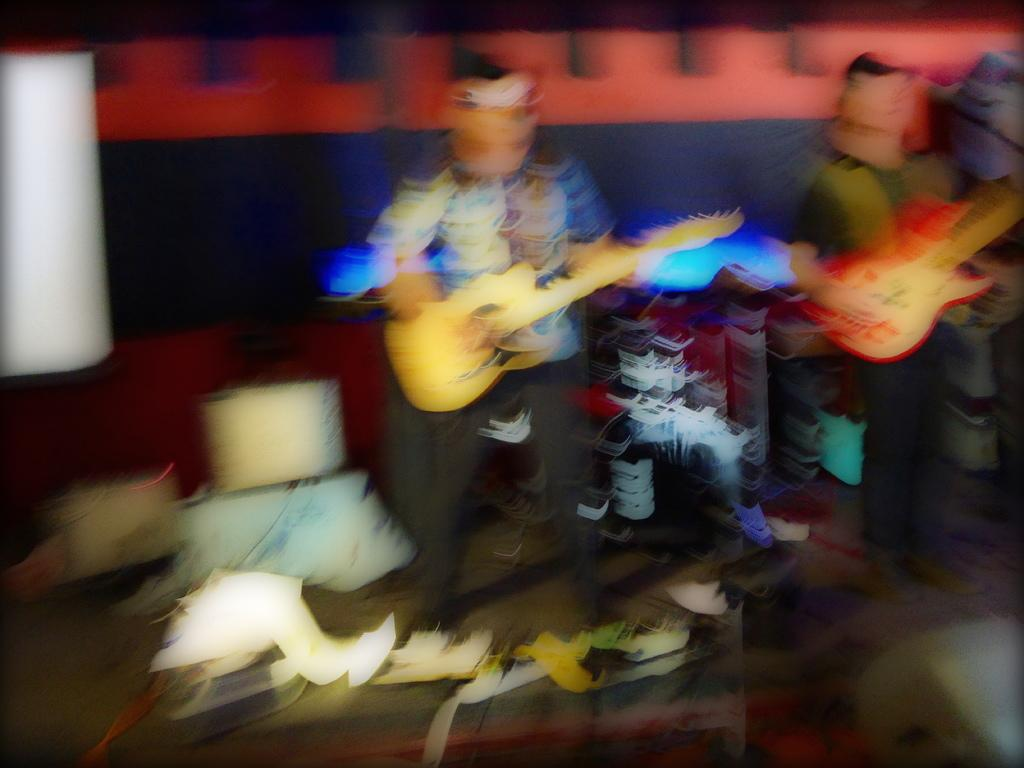What is the overall quality of the image? The image is blurry. What type of characters are present in the image? There are cartoons in the image. What are the cartoons holding in the image? The cartoons are holding guitars. Can you describe any other objects in the image? Due to the blurriness, it is difficult to accurately determine the specific details of other objects in the image. What type of skin condition can be seen on the cartoons in the image? There is no skin condition visible on the cartoons in the image, as they are not real people but animated characters. 